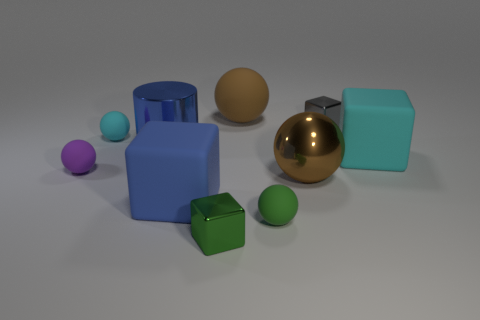Which object stands out the most to you and why? The golden sphere catches the eye instantly due to its shiny reflective surface that stands in contrast with the matte finishes of the other objects. Its central positioning among the array of objects also highlights its prominence. How does the golden sphere compare in size to the other objects? The golden sphere is medium-sized when compared to the other objects in the image. It's larger than the small spheres and the cube but smaller compared to the large cylinders and the square block. 